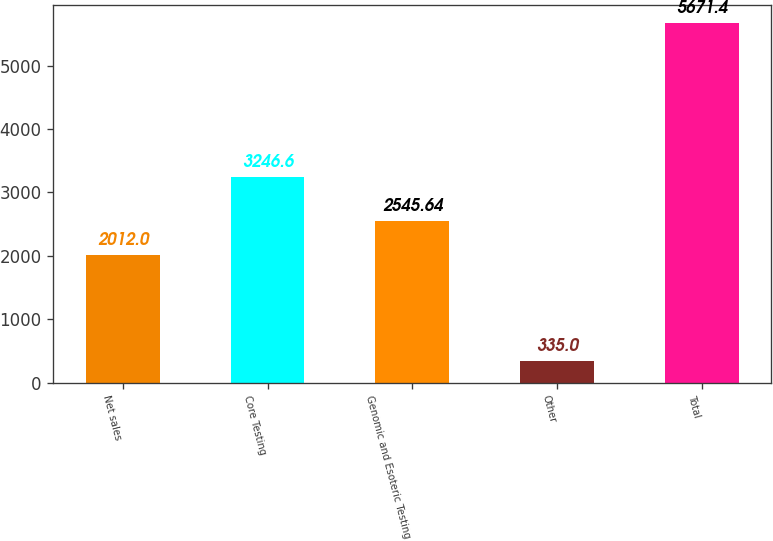Convert chart to OTSL. <chart><loc_0><loc_0><loc_500><loc_500><bar_chart><fcel>Net sales<fcel>Core Testing<fcel>Genomic and Esoteric Testing<fcel>Other<fcel>Total<nl><fcel>2012<fcel>3246.6<fcel>2545.64<fcel>335<fcel>5671.4<nl></chart> 